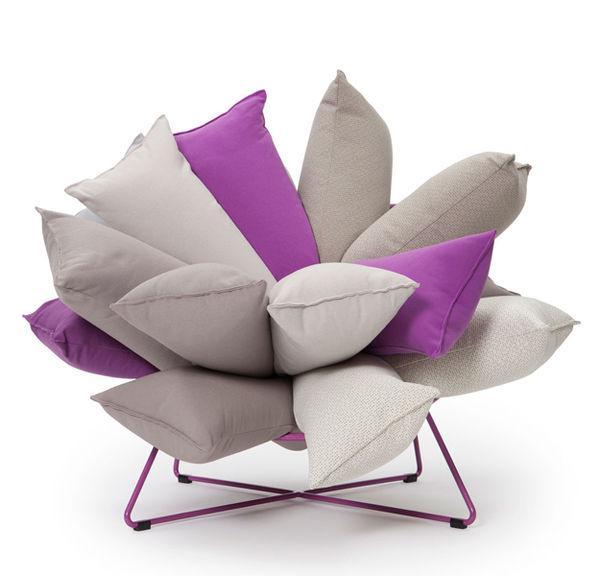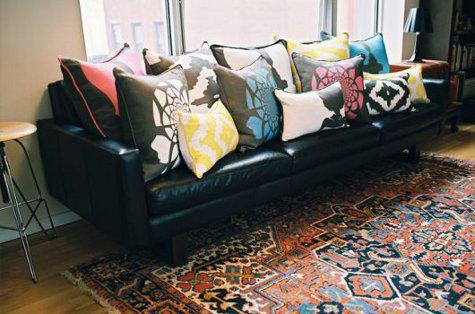The first image is the image on the left, the second image is the image on the right. Analyze the images presented: Is the assertion "In one image, pillows are stacked five across to form a couch-like seating area." valid? Answer yes or no. No. 